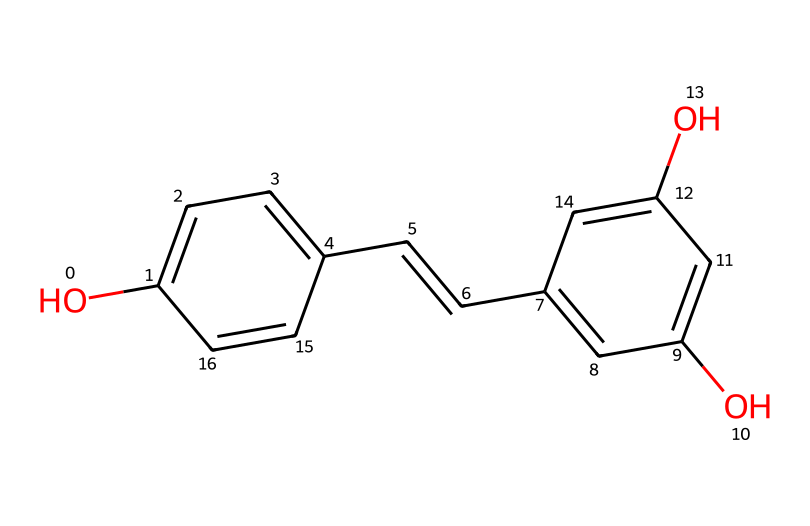What is the molecular formula of resveratrol? To determine the molecular formula, one counts the number of each type of atom in the structure. The structure includes carbon (C), hydrogen (H), and oxygen (O) atoms, totaling 14 carbons, 12 hydrogens, and 3 oxygens. Hence, the molecular formula is C14H12O3.
Answer: C14H12O3 How many hydroxyl (–OH) groups are present in resveratrol? By examining the structure, one can identify the hydroxyl groups, which are represented by –OH. There are three such groups in the structure, located on different aromatic rings.
Answer: 3 What is the structure type of resveratrol? The compound can be categorized based on the presence of multiple aromatic rings and double bonds; thus it is classified as a polyphenolic compound. The two aromatic rings connected by a double bond confirm its classification.
Answer: polyphenol How many double bonds are present in resveratrol? Inspecting the structure reveals two double bonds, one in the chain connecting the two aromatic rings and another in the aromatic structure itself.
Answer: 2 What functional groups are identified in resveratrol? The structure contains hydroxyl (–OH) functional groups and also features vinyl (–C=C–) associated with the carbon backbone. The identification is based on the presence of these specific groups.
Answer: hydroxyl, vinyl What kind of antioxidants does resveratrol belong to? Resveratrol is a natural antioxidant, characterized by its ability to neutralize free radicals, which is observed due to its polyphenolic structure that contributes to its antioxidant properties.
Answer: natural antioxidant 